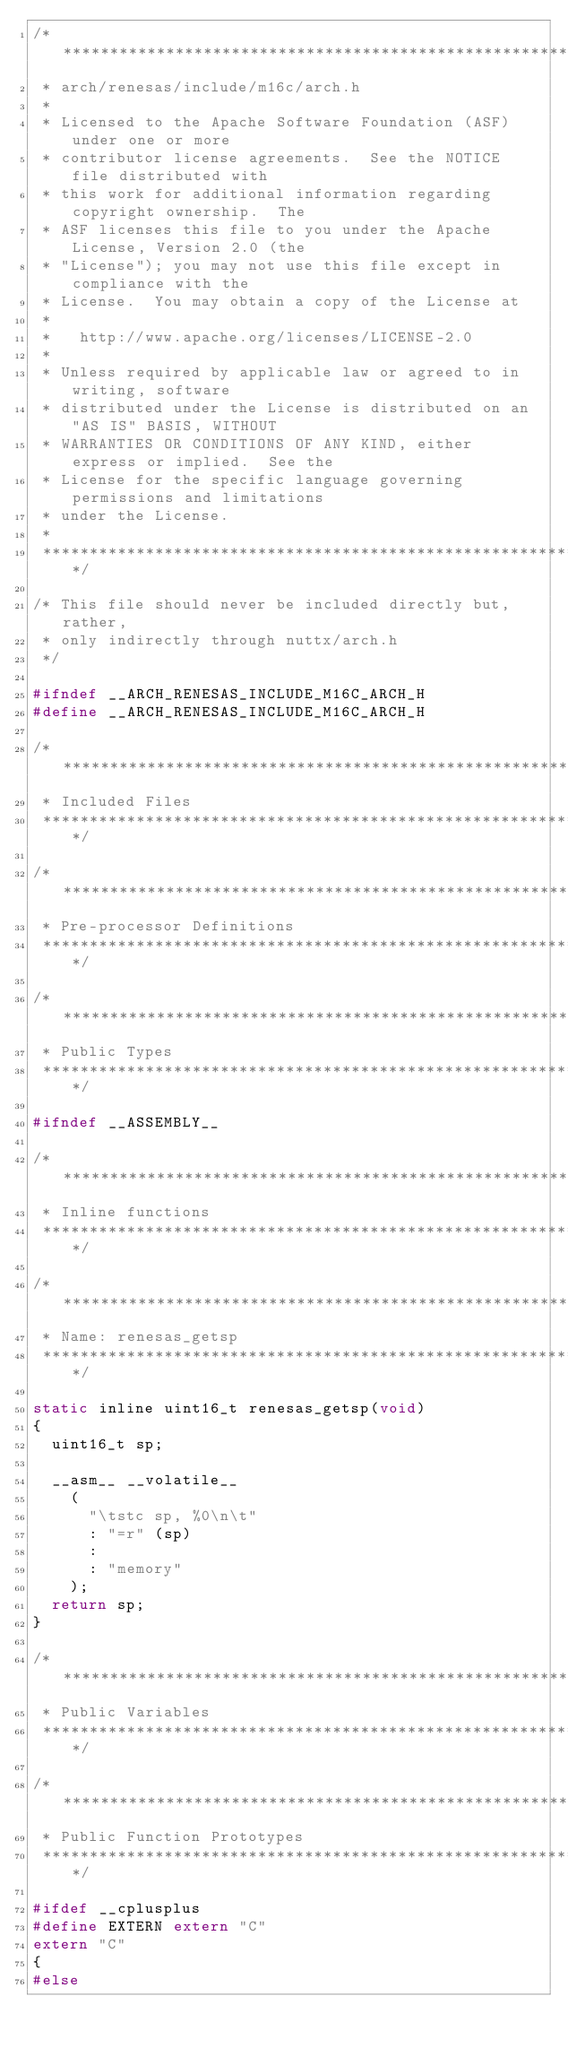<code> <loc_0><loc_0><loc_500><loc_500><_C_>/****************************************************************************
 * arch/renesas/include/m16c/arch.h
 *
 * Licensed to the Apache Software Foundation (ASF) under one or more
 * contributor license agreements.  See the NOTICE file distributed with
 * this work for additional information regarding copyright ownership.  The
 * ASF licenses this file to you under the Apache License, Version 2.0 (the
 * "License"); you may not use this file except in compliance with the
 * License.  You may obtain a copy of the License at
 *
 *   http://www.apache.org/licenses/LICENSE-2.0
 *
 * Unless required by applicable law or agreed to in writing, software
 * distributed under the License is distributed on an "AS IS" BASIS, WITHOUT
 * WARRANTIES OR CONDITIONS OF ANY KIND, either express or implied.  See the
 * License for the specific language governing permissions and limitations
 * under the License.
 *
 ****************************************************************************/

/* This file should never be included directly but, rather,
 * only indirectly through nuttx/arch.h
 */

#ifndef __ARCH_RENESAS_INCLUDE_M16C_ARCH_H
#define __ARCH_RENESAS_INCLUDE_M16C_ARCH_H

/****************************************************************************
 * Included Files
 ****************************************************************************/

/****************************************************************************
 * Pre-processor Definitions
 ****************************************************************************/

/****************************************************************************
 * Public Types
 ****************************************************************************/

#ifndef __ASSEMBLY__

/****************************************************************************
 * Inline functions
 ****************************************************************************/

/****************************************************************************
 * Name: renesas_getsp
 ****************************************************************************/

static inline uint16_t renesas_getsp(void)
{
  uint16_t sp;

  __asm__ __volatile__
    (
      "\tstc sp, %0\n\t"
      : "=r" (sp)
      :
      : "memory"
    );
  return sp;
}

/****************************************************************************
 * Public Variables
 ****************************************************************************/

/****************************************************************************
 * Public Function Prototypes
 ****************************************************************************/

#ifdef __cplusplus
#define EXTERN extern "C"
extern "C"
{
#else</code> 